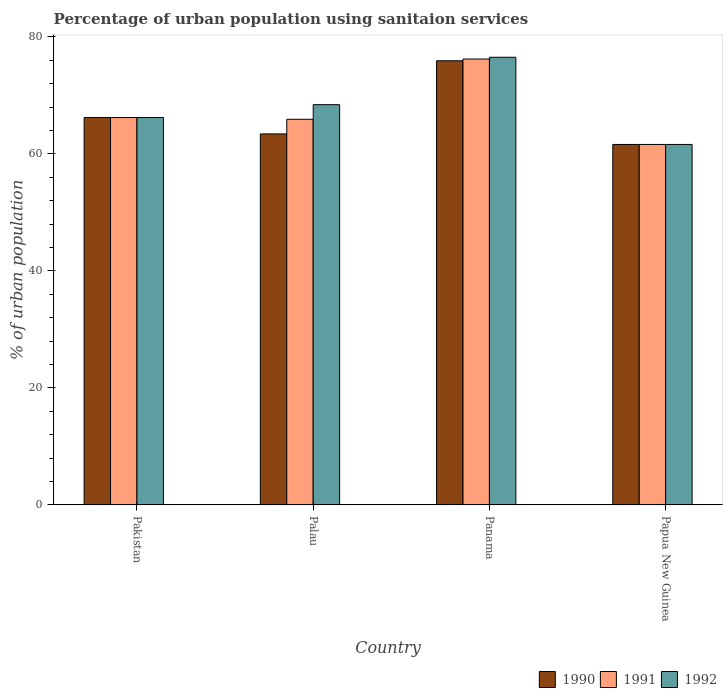How many bars are there on the 4th tick from the left?
Give a very brief answer. 3. How many bars are there on the 1st tick from the right?
Keep it short and to the point. 3. What is the label of the 4th group of bars from the left?
Provide a short and direct response. Papua New Guinea. In how many cases, is the number of bars for a given country not equal to the number of legend labels?
Your answer should be compact. 0. What is the percentage of urban population using sanitaion services in 1992 in Palau?
Your answer should be compact. 68.4. Across all countries, what is the maximum percentage of urban population using sanitaion services in 1990?
Your answer should be very brief. 75.9. Across all countries, what is the minimum percentage of urban population using sanitaion services in 1992?
Offer a very short reply. 61.6. In which country was the percentage of urban population using sanitaion services in 1991 maximum?
Make the answer very short. Panama. In which country was the percentage of urban population using sanitaion services in 1990 minimum?
Give a very brief answer. Papua New Guinea. What is the total percentage of urban population using sanitaion services in 1992 in the graph?
Your response must be concise. 272.7. What is the difference between the percentage of urban population using sanitaion services in 1991 in Panama and that in Papua New Guinea?
Your response must be concise. 14.6. What is the difference between the percentage of urban population using sanitaion services in 1991 in Papua New Guinea and the percentage of urban population using sanitaion services in 1990 in Palau?
Provide a short and direct response. -1.8. What is the average percentage of urban population using sanitaion services in 1992 per country?
Make the answer very short. 68.18. What is the ratio of the percentage of urban population using sanitaion services in 1992 in Palau to that in Panama?
Your answer should be very brief. 0.89. Is the percentage of urban population using sanitaion services in 1992 in Pakistan less than that in Palau?
Offer a very short reply. Yes. Is the difference between the percentage of urban population using sanitaion services in 1991 in Pakistan and Palau greater than the difference between the percentage of urban population using sanitaion services in 1990 in Pakistan and Palau?
Your answer should be compact. No. What is the difference between the highest and the second highest percentage of urban population using sanitaion services in 1990?
Your response must be concise. -9.7. What is the difference between the highest and the lowest percentage of urban population using sanitaion services in 1992?
Offer a very short reply. 14.9. Is the sum of the percentage of urban population using sanitaion services in 1990 in Palau and Panama greater than the maximum percentage of urban population using sanitaion services in 1991 across all countries?
Ensure brevity in your answer.  Yes. What does the 1st bar from the right in Pakistan represents?
Provide a succinct answer. 1992. Is it the case that in every country, the sum of the percentage of urban population using sanitaion services in 1990 and percentage of urban population using sanitaion services in 1992 is greater than the percentage of urban population using sanitaion services in 1991?
Offer a terse response. Yes. Are all the bars in the graph horizontal?
Your answer should be compact. No. How many countries are there in the graph?
Provide a succinct answer. 4. What is the difference between two consecutive major ticks on the Y-axis?
Your answer should be very brief. 20. Where does the legend appear in the graph?
Your response must be concise. Bottom right. How are the legend labels stacked?
Offer a terse response. Horizontal. What is the title of the graph?
Provide a succinct answer. Percentage of urban population using sanitaion services. What is the label or title of the Y-axis?
Your answer should be compact. % of urban population. What is the % of urban population in 1990 in Pakistan?
Your answer should be compact. 66.2. What is the % of urban population of 1991 in Pakistan?
Make the answer very short. 66.2. What is the % of urban population of 1992 in Pakistan?
Offer a very short reply. 66.2. What is the % of urban population in 1990 in Palau?
Your answer should be very brief. 63.4. What is the % of urban population of 1991 in Palau?
Offer a terse response. 65.9. What is the % of urban population in 1992 in Palau?
Provide a short and direct response. 68.4. What is the % of urban population in 1990 in Panama?
Your answer should be very brief. 75.9. What is the % of urban population in 1991 in Panama?
Provide a short and direct response. 76.2. What is the % of urban population in 1992 in Panama?
Make the answer very short. 76.5. What is the % of urban population in 1990 in Papua New Guinea?
Provide a short and direct response. 61.6. What is the % of urban population of 1991 in Papua New Guinea?
Your response must be concise. 61.6. What is the % of urban population of 1992 in Papua New Guinea?
Ensure brevity in your answer.  61.6. Across all countries, what is the maximum % of urban population of 1990?
Your answer should be very brief. 75.9. Across all countries, what is the maximum % of urban population of 1991?
Give a very brief answer. 76.2. Across all countries, what is the maximum % of urban population in 1992?
Give a very brief answer. 76.5. Across all countries, what is the minimum % of urban population in 1990?
Make the answer very short. 61.6. Across all countries, what is the minimum % of urban population of 1991?
Make the answer very short. 61.6. Across all countries, what is the minimum % of urban population in 1992?
Provide a succinct answer. 61.6. What is the total % of urban population of 1990 in the graph?
Provide a succinct answer. 267.1. What is the total % of urban population of 1991 in the graph?
Ensure brevity in your answer.  269.9. What is the total % of urban population of 1992 in the graph?
Ensure brevity in your answer.  272.7. What is the difference between the % of urban population of 1990 in Pakistan and that in Palau?
Your answer should be compact. 2.8. What is the difference between the % of urban population of 1991 in Pakistan and that in Palau?
Your answer should be compact. 0.3. What is the difference between the % of urban population in 1991 in Pakistan and that in Panama?
Your answer should be compact. -10. What is the difference between the % of urban population in 1990 in Pakistan and that in Papua New Guinea?
Ensure brevity in your answer.  4.6. What is the difference between the % of urban population of 1992 in Pakistan and that in Papua New Guinea?
Ensure brevity in your answer.  4.6. What is the difference between the % of urban population in 1990 in Palau and that in Panama?
Your response must be concise. -12.5. What is the difference between the % of urban population of 1991 in Palau and that in Panama?
Give a very brief answer. -10.3. What is the difference between the % of urban population in 1990 in Palau and that in Papua New Guinea?
Keep it short and to the point. 1.8. What is the difference between the % of urban population of 1991 in Palau and that in Papua New Guinea?
Provide a succinct answer. 4.3. What is the difference between the % of urban population of 1992 in Palau and that in Papua New Guinea?
Provide a short and direct response. 6.8. What is the difference between the % of urban population of 1990 in Panama and that in Papua New Guinea?
Your response must be concise. 14.3. What is the difference between the % of urban population in 1991 in Panama and that in Papua New Guinea?
Your response must be concise. 14.6. What is the difference between the % of urban population of 1992 in Panama and that in Papua New Guinea?
Ensure brevity in your answer.  14.9. What is the difference between the % of urban population in 1990 in Pakistan and the % of urban population in 1992 in Palau?
Provide a short and direct response. -2.2. What is the difference between the % of urban population in 1991 in Pakistan and the % of urban population in 1992 in Panama?
Your response must be concise. -10.3. What is the difference between the % of urban population in 1990 in Pakistan and the % of urban population in 1991 in Papua New Guinea?
Keep it short and to the point. 4.6. What is the difference between the % of urban population in 1991 in Pakistan and the % of urban population in 1992 in Papua New Guinea?
Provide a short and direct response. 4.6. What is the difference between the % of urban population in 1990 in Palau and the % of urban population in 1991 in Panama?
Your answer should be very brief. -12.8. What is the difference between the % of urban population of 1991 in Palau and the % of urban population of 1992 in Panama?
Ensure brevity in your answer.  -10.6. What is the difference between the % of urban population of 1990 in Palau and the % of urban population of 1991 in Papua New Guinea?
Give a very brief answer. 1.8. What is the difference between the % of urban population of 1990 in Palau and the % of urban population of 1992 in Papua New Guinea?
Your answer should be compact. 1.8. What is the difference between the % of urban population of 1990 in Panama and the % of urban population of 1992 in Papua New Guinea?
Offer a very short reply. 14.3. What is the average % of urban population in 1990 per country?
Offer a very short reply. 66.78. What is the average % of urban population of 1991 per country?
Make the answer very short. 67.47. What is the average % of urban population of 1992 per country?
Offer a terse response. 68.17. What is the difference between the % of urban population in 1990 and % of urban population in 1991 in Pakistan?
Your answer should be compact. 0. What is the difference between the % of urban population in 1990 and % of urban population in 1992 in Pakistan?
Offer a terse response. 0. What is the difference between the % of urban population in 1990 and % of urban population in 1991 in Palau?
Your answer should be compact. -2.5. What is the difference between the % of urban population of 1990 and % of urban population of 1992 in Palau?
Ensure brevity in your answer.  -5. What is the difference between the % of urban population of 1990 and % of urban population of 1992 in Papua New Guinea?
Offer a terse response. 0. What is the ratio of the % of urban population of 1990 in Pakistan to that in Palau?
Make the answer very short. 1.04. What is the ratio of the % of urban population in 1992 in Pakistan to that in Palau?
Offer a terse response. 0.97. What is the ratio of the % of urban population of 1990 in Pakistan to that in Panama?
Keep it short and to the point. 0.87. What is the ratio of the % of urban population in 1991 in Pakistan to that in Panama?
Offer a terse response. 0.87. What is the ratio of the % of urban population of 1992 in Pakistan to that in Panama?
Provide a short and direct response. 0.87. What is the ratio of the % of urban population of 1990 in Pakistan to that in Papua New Guinea?
Give a very brief answer. 1.07. What is the ratio of the % of urban population of 1991 in Pakistan to that in Papua New Guinea?
Your response must be concise. 1.07. What is the ratio of the % of urban population of 1992 in Pakistan to that in Papua New Guinea?
Ensure brevity in your answer.  1.07. What is the ratio of the % of urban population in 1990 in Palau to that in Panama?
Your response must be concise. 0.84. What is the ratio of the % of urban population in 1991 in Palau to that in Panama?
Your answer should be very brief. 0.86. What is the ratio of the % of urban population in 1992 in Palau to that in Panama?
Your answer should be compact. 0.89. What is the ratio of the % of urban population in 1990 in Palau to that in Papua New Guinea?
Keep it short and to the point. 1.03. What is the ratio of the % of urban population of 1991 in Palau to that in Papua New Guinea?
Ensure brevity in your answer.  1.07. What is the ratio of the % of urban population in 1992 in Palau to that in Papua New Guinea?
Your answer should be very brief. 1.11. What is the ratio of the % of urban population of 1990 in Panama to that in Papua New Guinea?
Ensure brevity in your answer.  1.23. What is the ratio of the % of urban population of 1991 in Panama to that in Papua New Guinea?
Offer a terse response. 1.24. What is the ratio of the % of urban population of 1992 in Panama to that in Papua New Guinea?
Offer a very short reply. 1.24. What is the difference between the highest and the second highest % of urban population in 1990?
Ensure brevity in your answer.  9.7. What is the difference between the highest and the second highest % of urban population of 1991?
Provide a short and direct response. 10. What is the difference between the highest and the lowest % of urban population in 1990?
Offer a terse response. 14.3. What is the difference between the highest and the lowest % of urban population of 1991?
Ensure brevity in your answer.  14.6. What is the difference between the highest and the lowest % of urban population in 1992?
Your response must be concise. 14.9. 